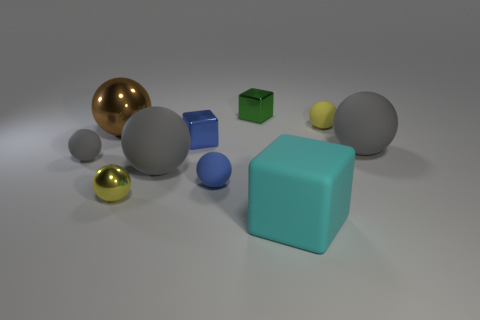Does the yellow sphere that is to the right of the tiny blue rubber object have the same material as the small object that is in front of the blue matte ball?
Your response must be concise. No. Do the gray rubber thing that is to the left of the brown shiny object and the cyan rubber thing have the same size?
Make the answer very short. No. There is a small metallic sphere; is its color the same as the sphere behind the brown sphere?
Give a very brief answer. Yes. The green object has what shape?
Provide a succinct answer. Cube. What number of objects are either rubber balls right of the green shiny cube or green shiny cubes?
Your response must be concise. 3. What is the size of the yellow ball that is the same material as the tiny gray sphere?
Provide a short and direct response. Small. Is the number of big cyan matte things that are left of the tiny yellow rubber object greater than the number of tiny purple objects?
Your answer should be very brief. Yes. Do the large cyan object and the metallic thing behind the large metallic object have the same shape?
Make the answer very short. Yes. How many big objects are either blue metal objects or green metal objects?
Keep it short and to the point. 0. There is a object that is the same color as the small metal ball; what size is it?
Your answer should be very brief. Small. 